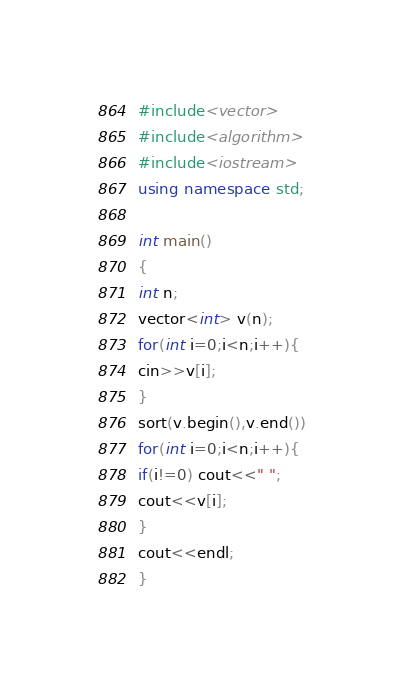<code> <loc_0><loc_0><loc_500><loc_500><_C++_>#include<vector>
#include<algorithm>
#include<iostream>
using namespace std;

int main()
{
int n;
vector<int> v(n);
for(int i=0;i<n;i++){
cin>>v[i];
}
sort(v.begin(),v.end())
for(int i=0;i<n;i++){
if(i!=0) cout<<" ";
cout<<v[i];
}
cout<<endl;
}</code> 